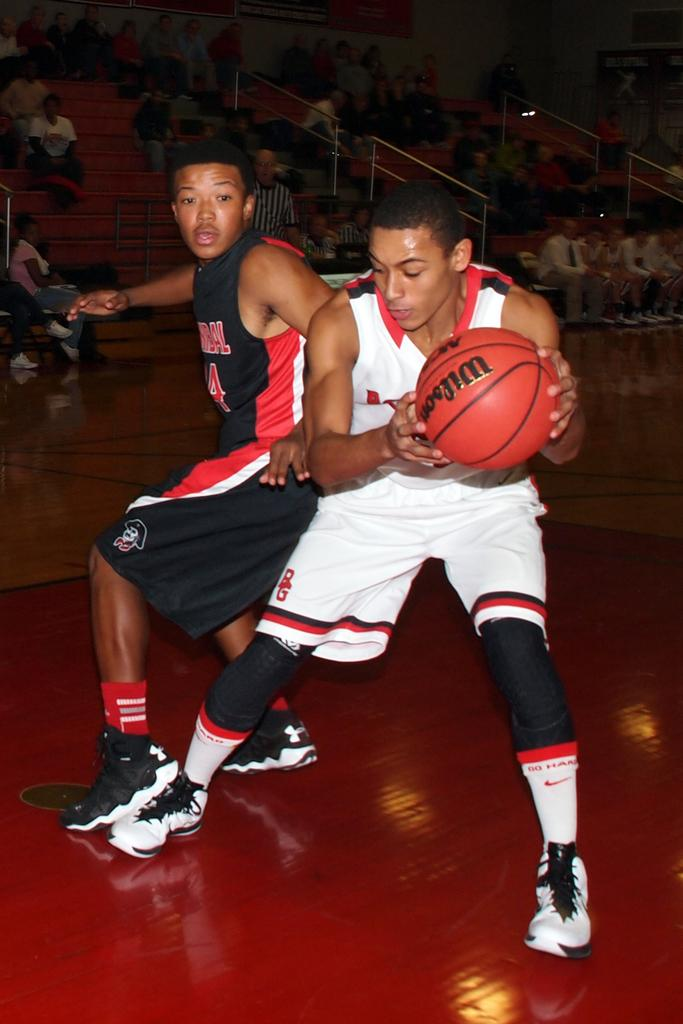Provide a one-sentence caption for the provided image. The basketball player held the basketball with the words "Wilson" written on it. 